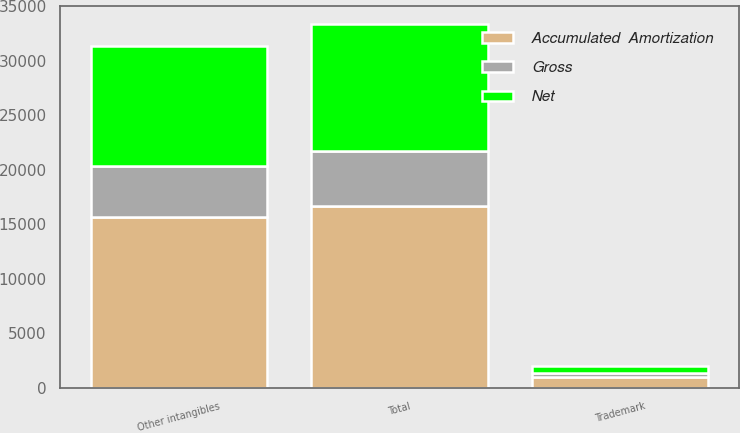Convert chart to OTSL. <chart><loc_0><loc_0><loc_500><loc_500><stacked_bar_chart><ecel><fcel>Trademark<fcel>Other intangibles<fcel>Total<nl><fcel>Accumulated  Amortization<fcel>1000<fcel>15700<fcel>16700<nl><fcel>Net<fcel>660<fcel>11042<fcel>11702<nl><fcel>Gross<fcel>340<fcel>4658<fcel>4998<nl></chart> 